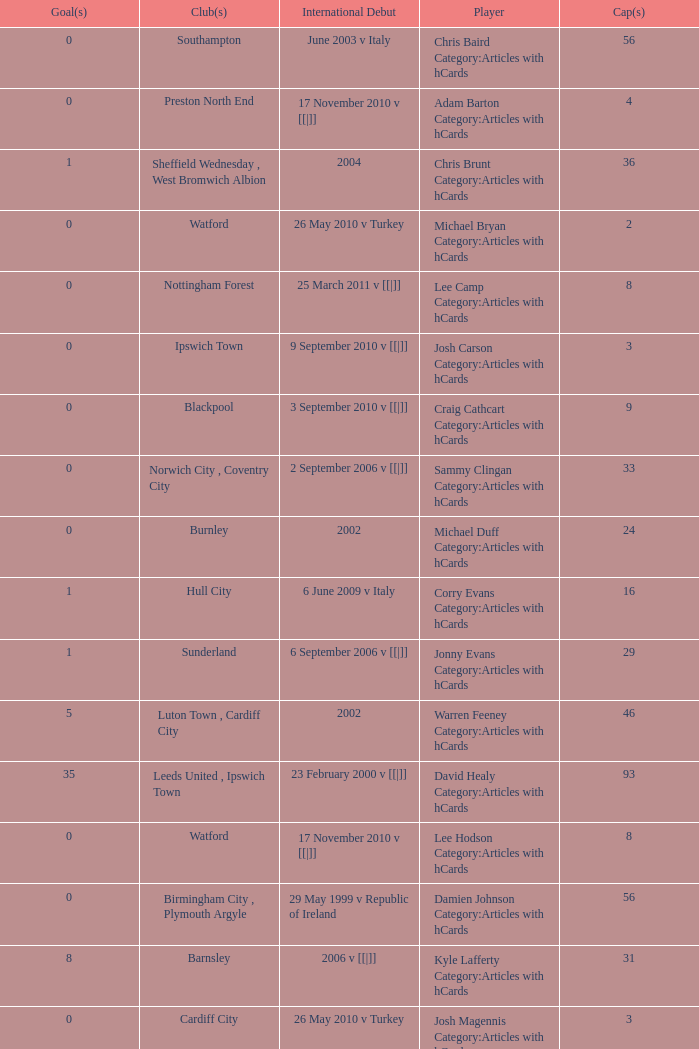How many players had 8 goals? 1.0. 